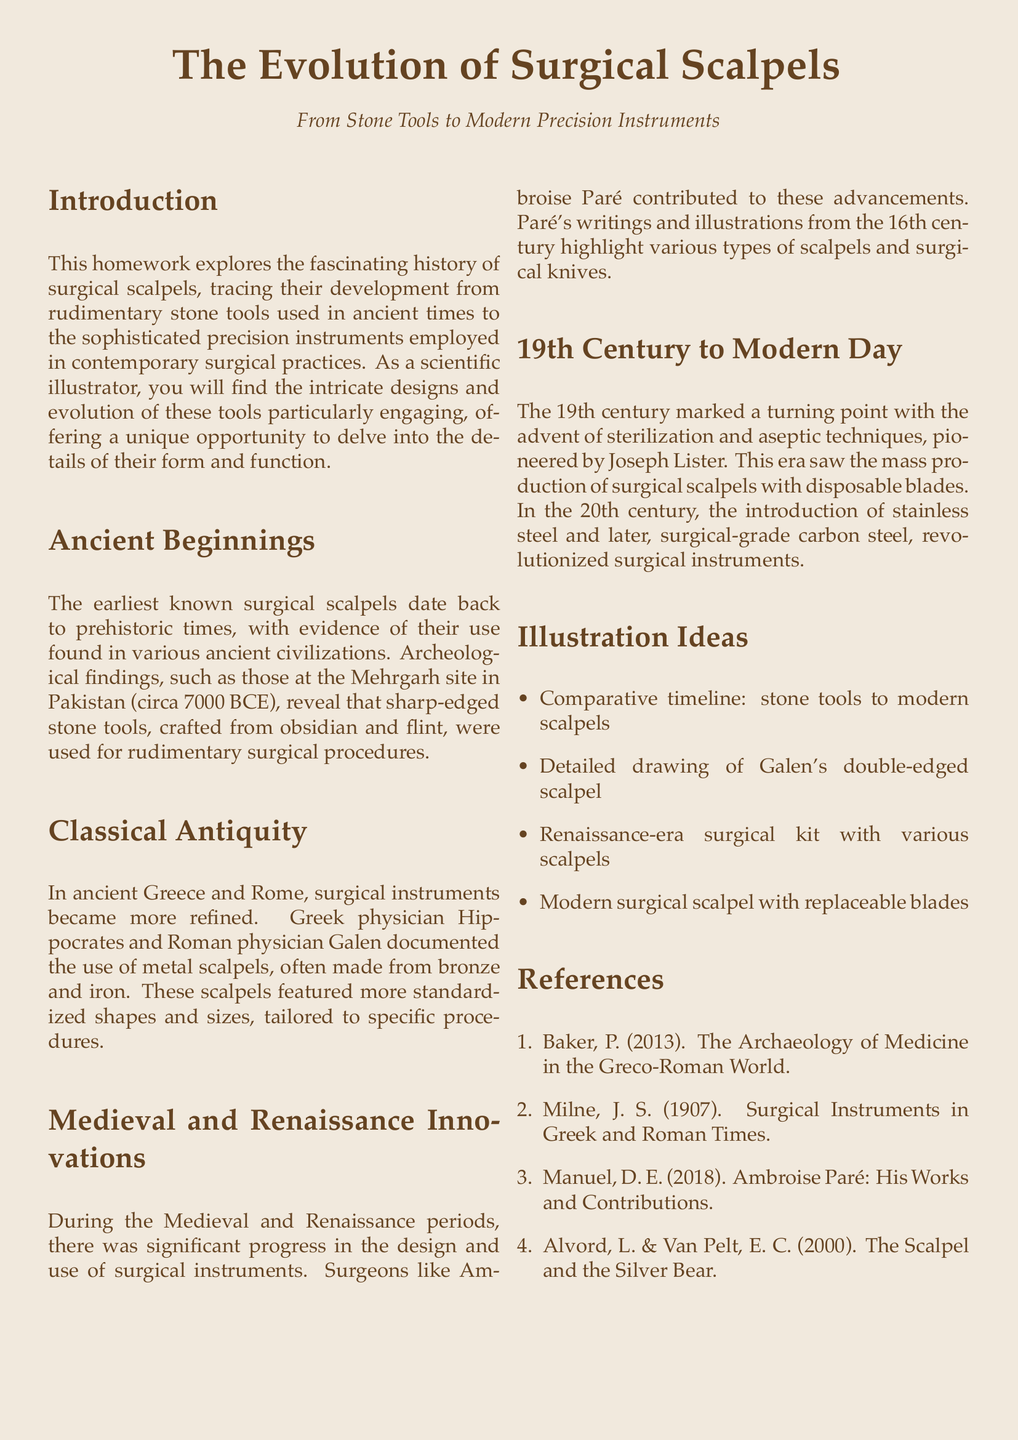What is the earliest known date for surgical scalpels? The document states that the earliest known surgical scalpels date back to prehistoric times, with findings at the Mehrgarh site circa 7000 BCE.
Answer: 7000 BCE Who documented the use of metal scalpels in ancient Greece? The document mentions that Greek physician Hippocrates documented the use of metal scalpels.
Answer: Hippocrates Which material revolutionized surgical instruments in the 20th century? The document indicates that the introduction of stainless steel revolutionized surgical instruments.
Answer: Stainless steel What significant contribution did Joseph Lister make in the 19th century? The document notes that Joseph Lister pioneered sterilization and aseptic techniques in the 19th century.
Answer: Sterilization Who was a key figure during the Renaissance that contributed to surgical instrument design? The document highlights Ambroise Paré as a key figure contributing to surgical instrument design during the Renaissance.
Answer: Ambroise Paré What illustration idea includes a comparative timeline? The document lists "Comparative timeline: stone tools to modern scalpels" as an illustration idea.
Answer: Comparative timeline: stone tools to modern scalpels How many references are cited in the document? The document lists a total of four references.
Answer: Four What type of instruments were used in Greece and Rome according to the document? The document states that metal scalpels were used in Greece and Rome.
Answer: Metal scalpels 